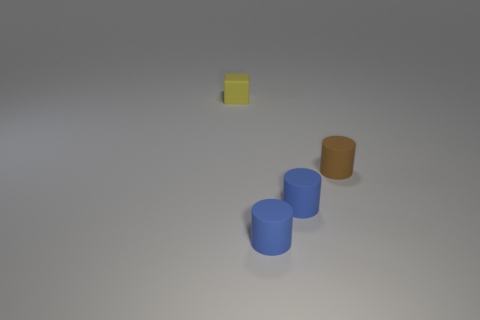Add 4 tiny yellow matte balls. How many objects exist? 8 Subtract all cylinders. How many objects are left? 1 Add 2 big red blocks. How many big red blocks exist? 2 Subtract 0 cyan blocks. How many objects are left? 4 Subtract all small spheres. Subtract all tiny brown cylinders. How many objects are left? 3 Add 3 brown rubber objects. How many brown rubber objects are left? 4 